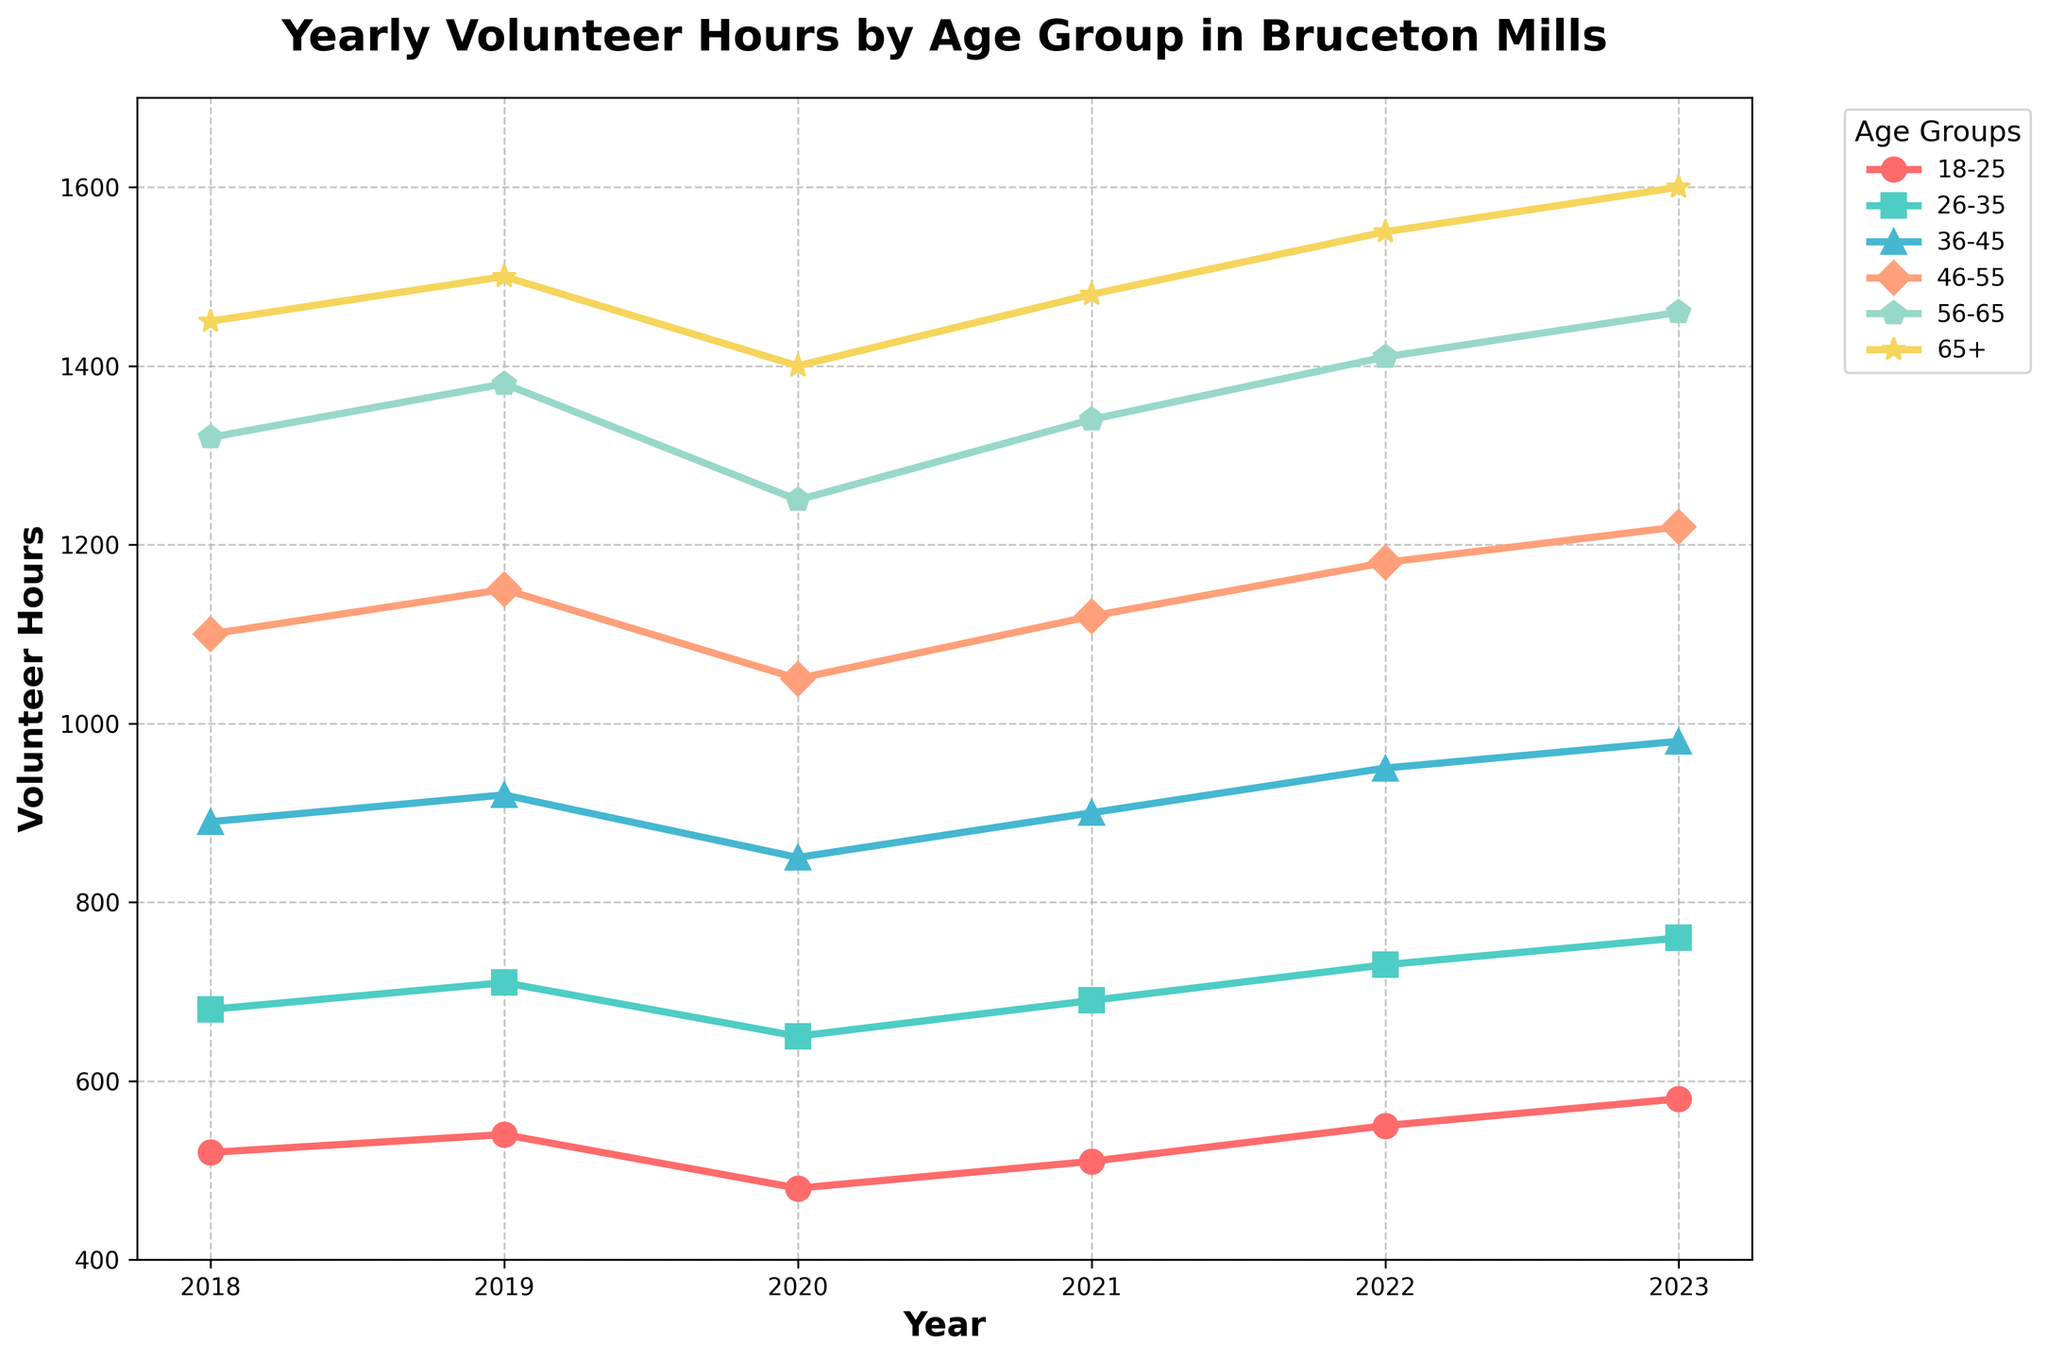Which age group has the highest volunteer hours in 2023? According to the chart, the age group 65+ has the highest volunteer hours in 2023. This is visually shown by the line reaching the highest point on the y-axis for that year.
Answer: 65+ What is the difference in volunteer hours between the age groups 36-45 and 46-55 in 2023? In 2023, the 36-45 age group has 980 volunteer hours and the 46-55 age group has 1220 volunteer hours. The difference is calculated as 1220 - 980.
Answer: 240 How have volunteer hours changed for the 26-35 age group from 2018 to 2023? The volunteer hours for the 26-35 age group in 2018 were 680 and increased to 760 in 2023. The change is calculated by subtracting 680 from 760.
Answer: Increased by 80 What was the average volunteer hours for the 56-65 age group from 2018 to 2023? Sum the volunteer hours for the 56-65 age group for each year from the chart (1320 + 1380 + 1250 + 1340 + 1410 + 1460) to get 8160. Then divide by the number of years (6).
Answer: 1360 Which age group showed the most consistent volunteer hours from 2018 to 2023? By observing the lines on the chart, the 18-25 age group shows relatively consistent, slight fluctuations over the years compared to other age groups.
Answer: 18-25 How did volunteer hours for the age group 65+ change from 2020 to 2021? In 2020, the 65+ age group had 1400 volunteer hours, and it increased to 1480 in 2021.
Answer: Increased by 80 What is the sum of volunteer hours across all age groups in 2022? Add the volunteer hours for each age group in 2022: (550 + 730 + 950 + 1180 + 1410 + 1550).
Answer: 6370 Which age group had the lowest volunteer hours in 2020, and how many hours were recorded? The 18-25 age group had the lowest volunteer hours in 2020, with 480 hours.
Answer: 18-25, 480 Compare the trend between the 46-55 and 56-65 age groups from 2018 to 2023. Which group showed a greater overall increase? The 46-55 age group increased from 1100 in 2018 to 1220 in 2023, a total increase of 120 hours. The 56-65 age group increased from 1320 in 2018 to 1460 in 2023, a total increase of 140 hours. Therefore, the 56-65 age group showed a greater overall increase.
Answer: 56-65 age group What can you infer about the overall trend of volunteer hours for all age groups from 2018 to 2023? Observing the chart, most age groups show an upward trend in volunteer hours from 2018 to 2023, suggesting an overall increase in community engagement over the years.
Answer: Overall increase 